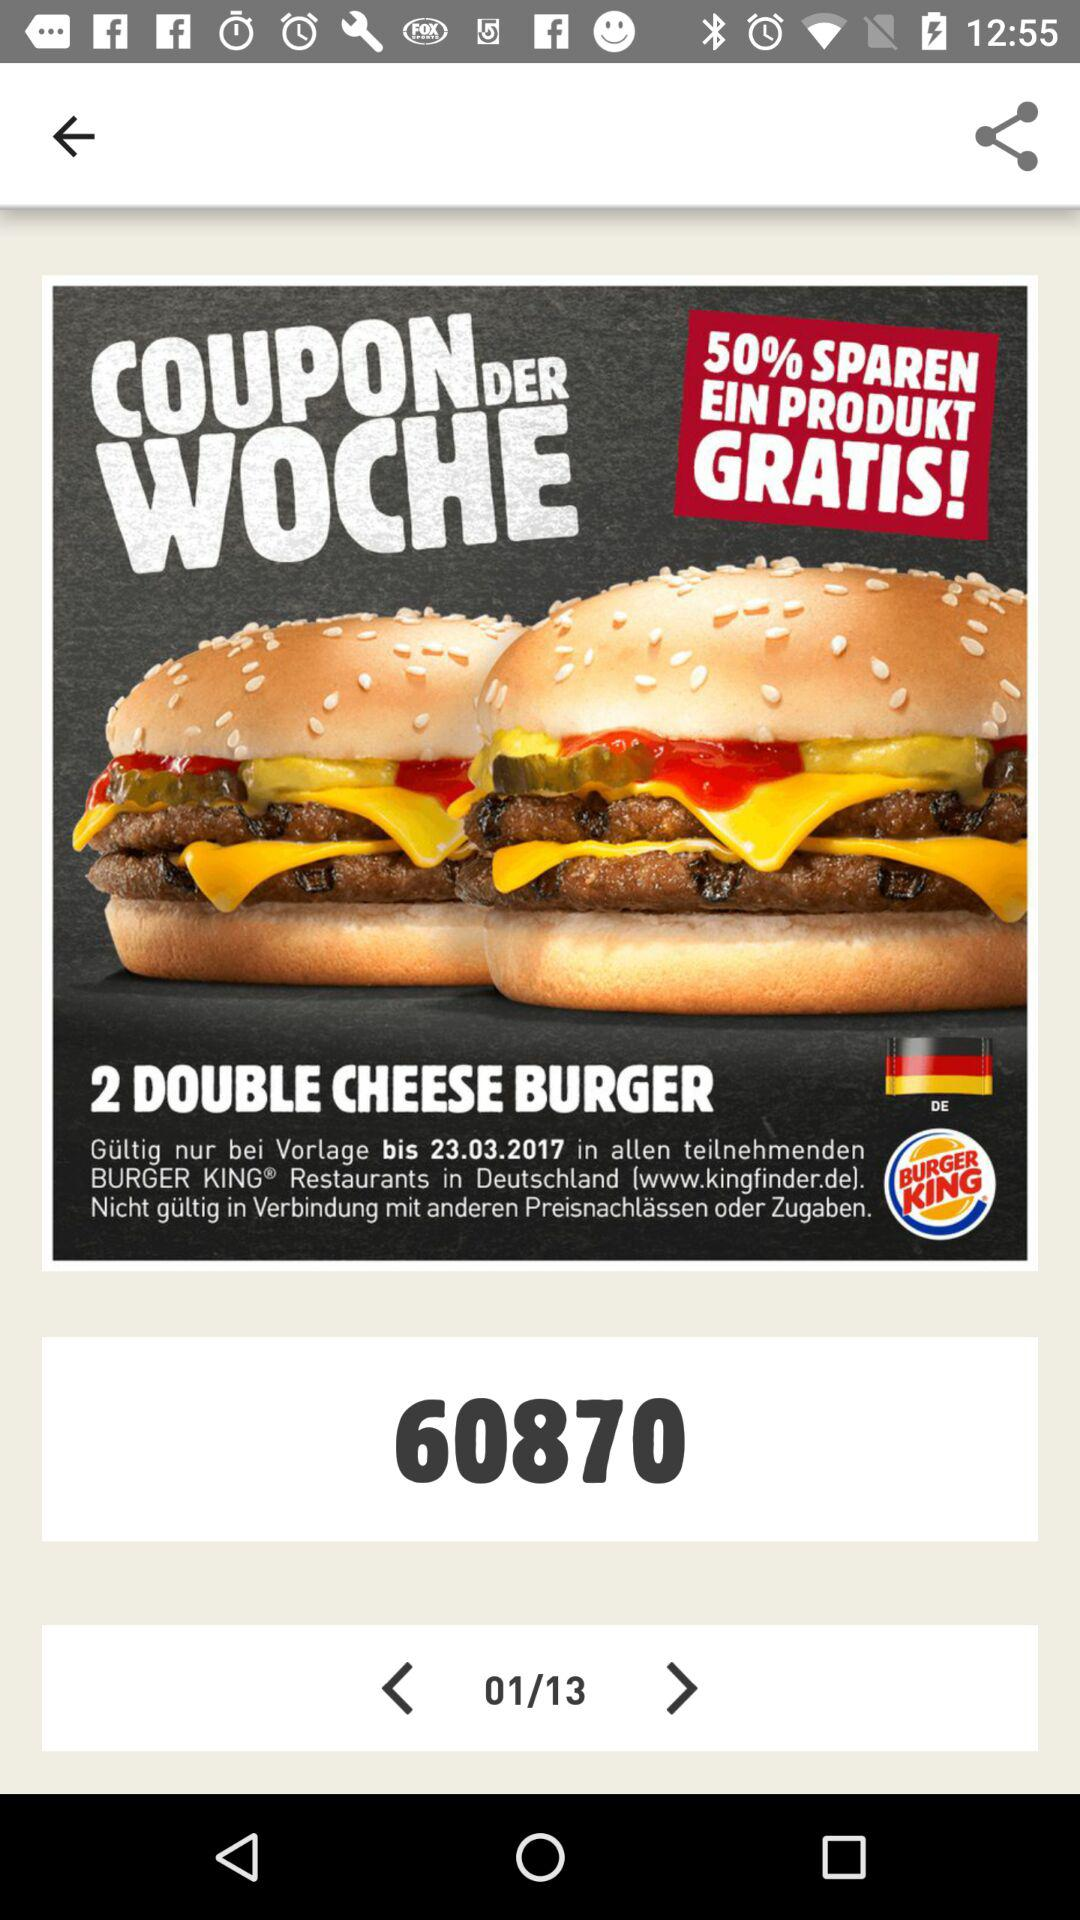What is the given coupon code? The given coupon code is "60870". 